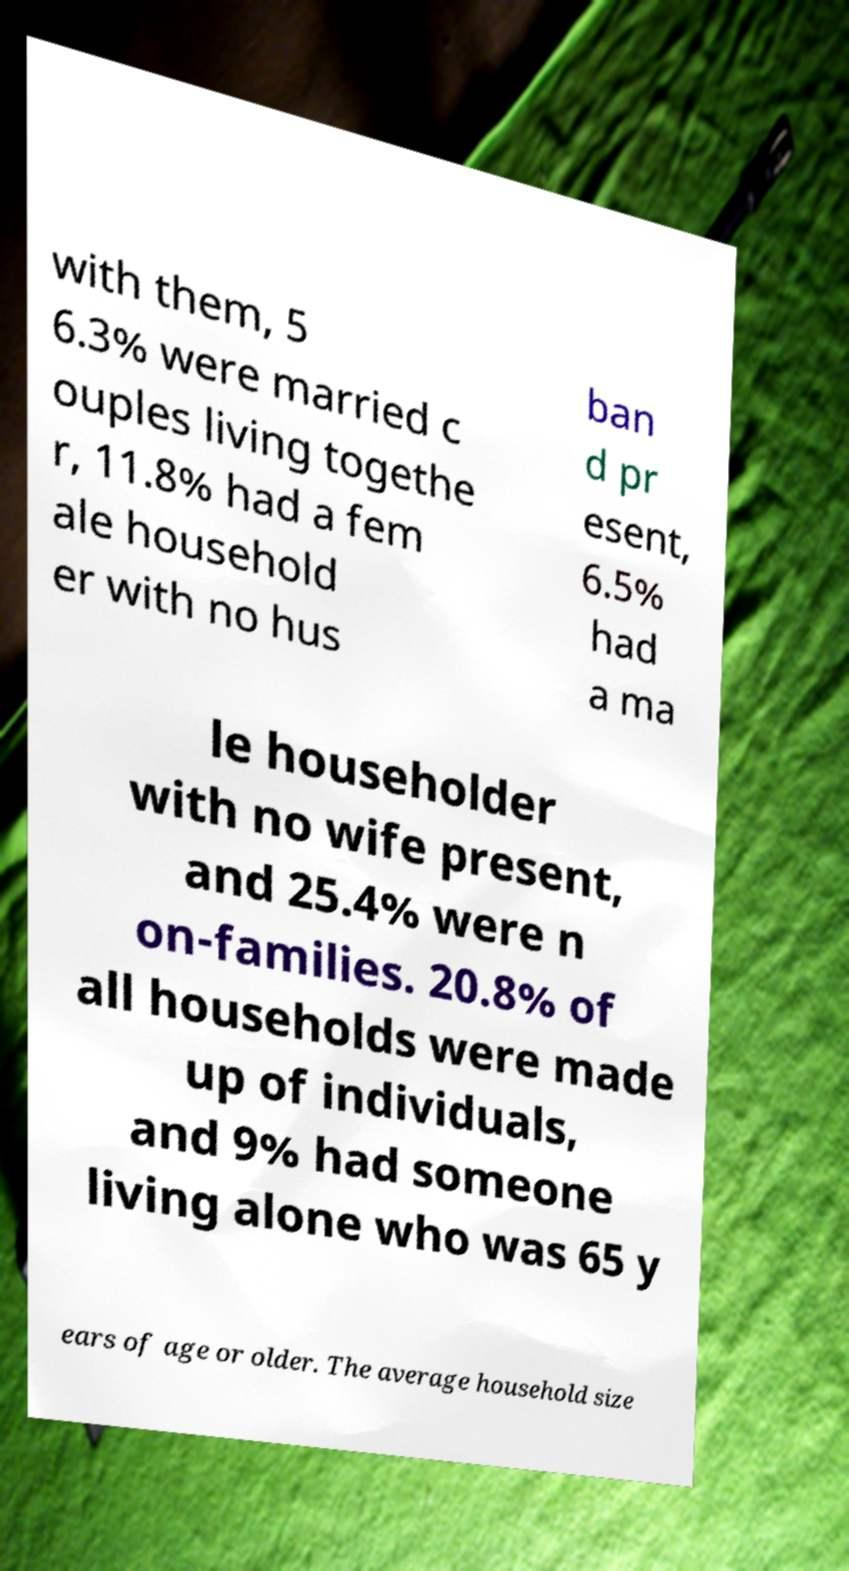For documentation purposes, I need the text within this image transcribed. Could you provide that? with them, 5 6.3% were married c ouples living togethe r, 11.8% had a fem ale household er with no hus ban d pr esent, 6.5% had a ma le householder with no wife present, and 25.4% were n on-families. 20.8% of all households were made up of individuals, and 9% had someone living alone who was 65 y ears of age or older. The average household size 